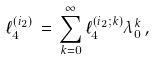Convert formula to latex. <formula><loc_0><loc_0><loc_500><loc_500>\ell _ { 4 } ^ { ( i _ { 2 } ) } \, = \, \sum _ { k = 0 } ^ { \infty } \ell _ { 4 } ^ { ( i _ { 2 } ; k ) } \lambda _ { 0 } ^ { k } \, ,</formula> 